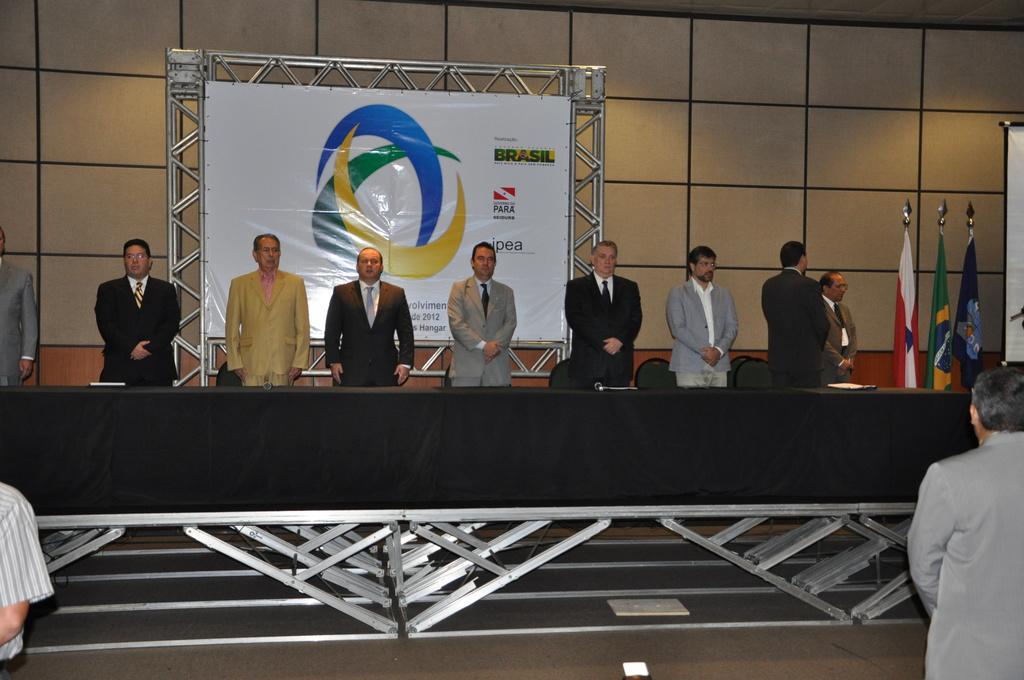How would you summarize this image in a sentence or two? In this image we can see some people standing and there is a table with some objects and we can see three flags on the right side of the image. There is a board with some text and logos and there are few chairs and we can see the wall. 